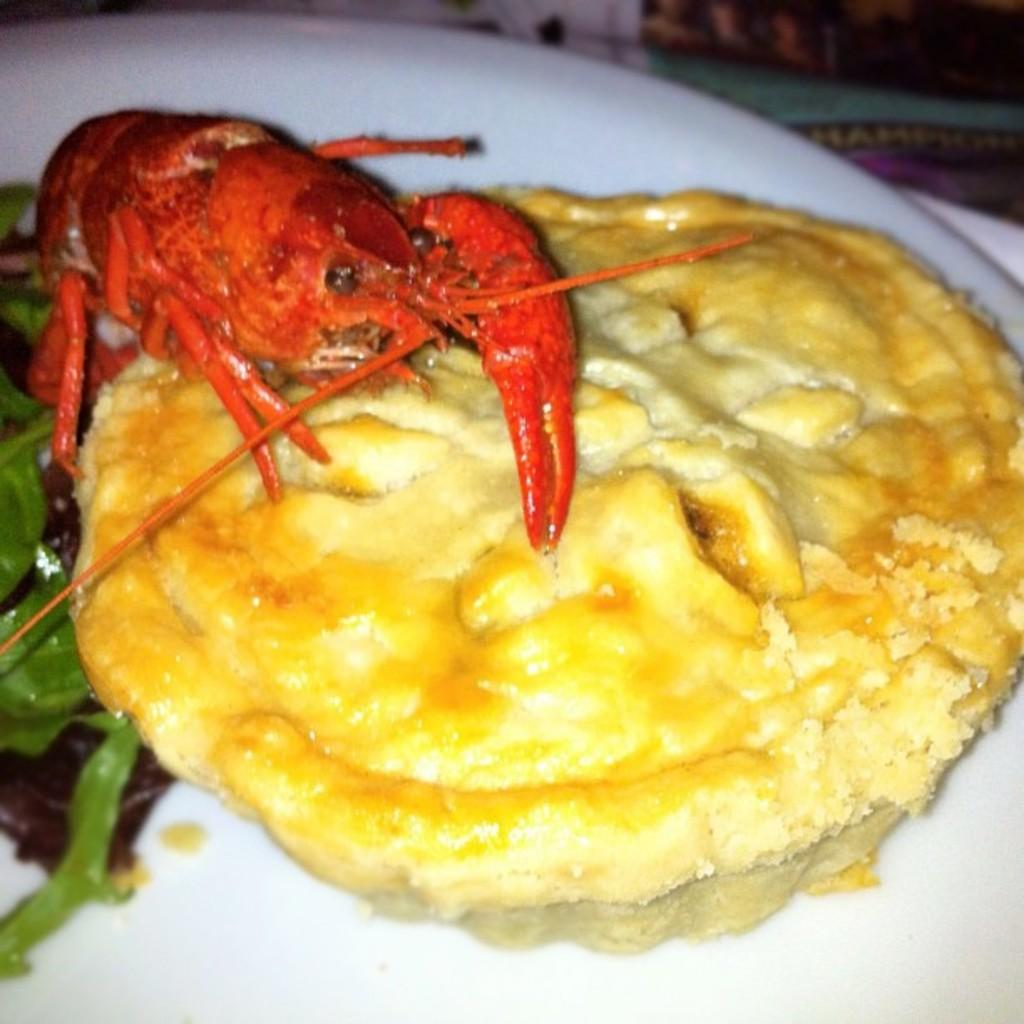What is present on the plate in the image? The plate contains food. What type of food can be seen on the plate? There is a crab on the plate. What type of legal advice can be obtained from the crab on the plate? There is no lawyer or legal advice present in the image; it features a plate with a crab on it. 